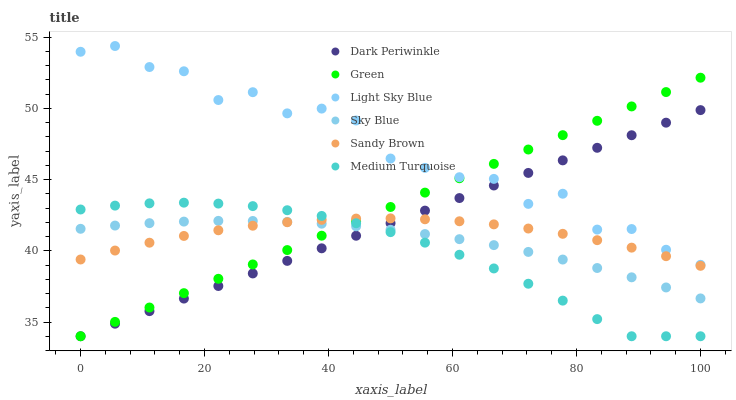Does Medium Turquoise have the minimum area under the curve?
Answer yes or no. Yes. Does Light Sky Blue have the maximum area under the curve?
Answer yes or no. Yes. Does Green have the minimum area under the curve?
Answer yes or no. No. Does Green have the maximum area under the curve?
Answer yes or no. No. Is Dark Periwinkle the smoothest?
Answer yes or no. Yes. Is Light Sky Blue the roughest?
Answer yes or no. Yes. Is Green the smoothest?
Answer yes or no. No. Is Green the roughest?
Answer yes or no. No. Does Green have the lowest value?
Answer yes or no. Yes. Does Sky Blue have the lowest value?
Answer yes or no. No. Does Light Sky Blue have the highest value?
Answer yes or no. Yes. Does Green have the highest value?
Answer yes or no. No. Is Sky Blue less than Light Sky Blue?
Answer yes or no. Yes. Is Light Sky Blue greater than Medium Turquoise?
Answer yes or no. Yes. Does Green intersect Light Sky Blue?
Answer yes or no. Yes. Is Green less than Light Sky Blue?
Answer yes or no. No. Is Green greater than Light Sky Blue?
Answer yes or no. No. Does Sky Blue intersect Light Sky Blue?
Answer yes or no. No. 